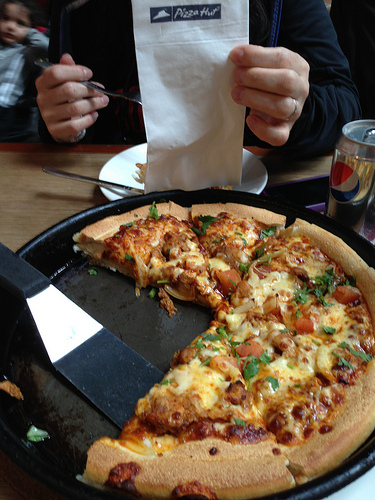Please provide the bounding box coordinate of the region this sentence describes: Man eating his pizza with a fork. The man eating his pizza with a fork can be located in the region marked by the coordinates approximately [0.19, 0.11, 0.41, 0.28]. 